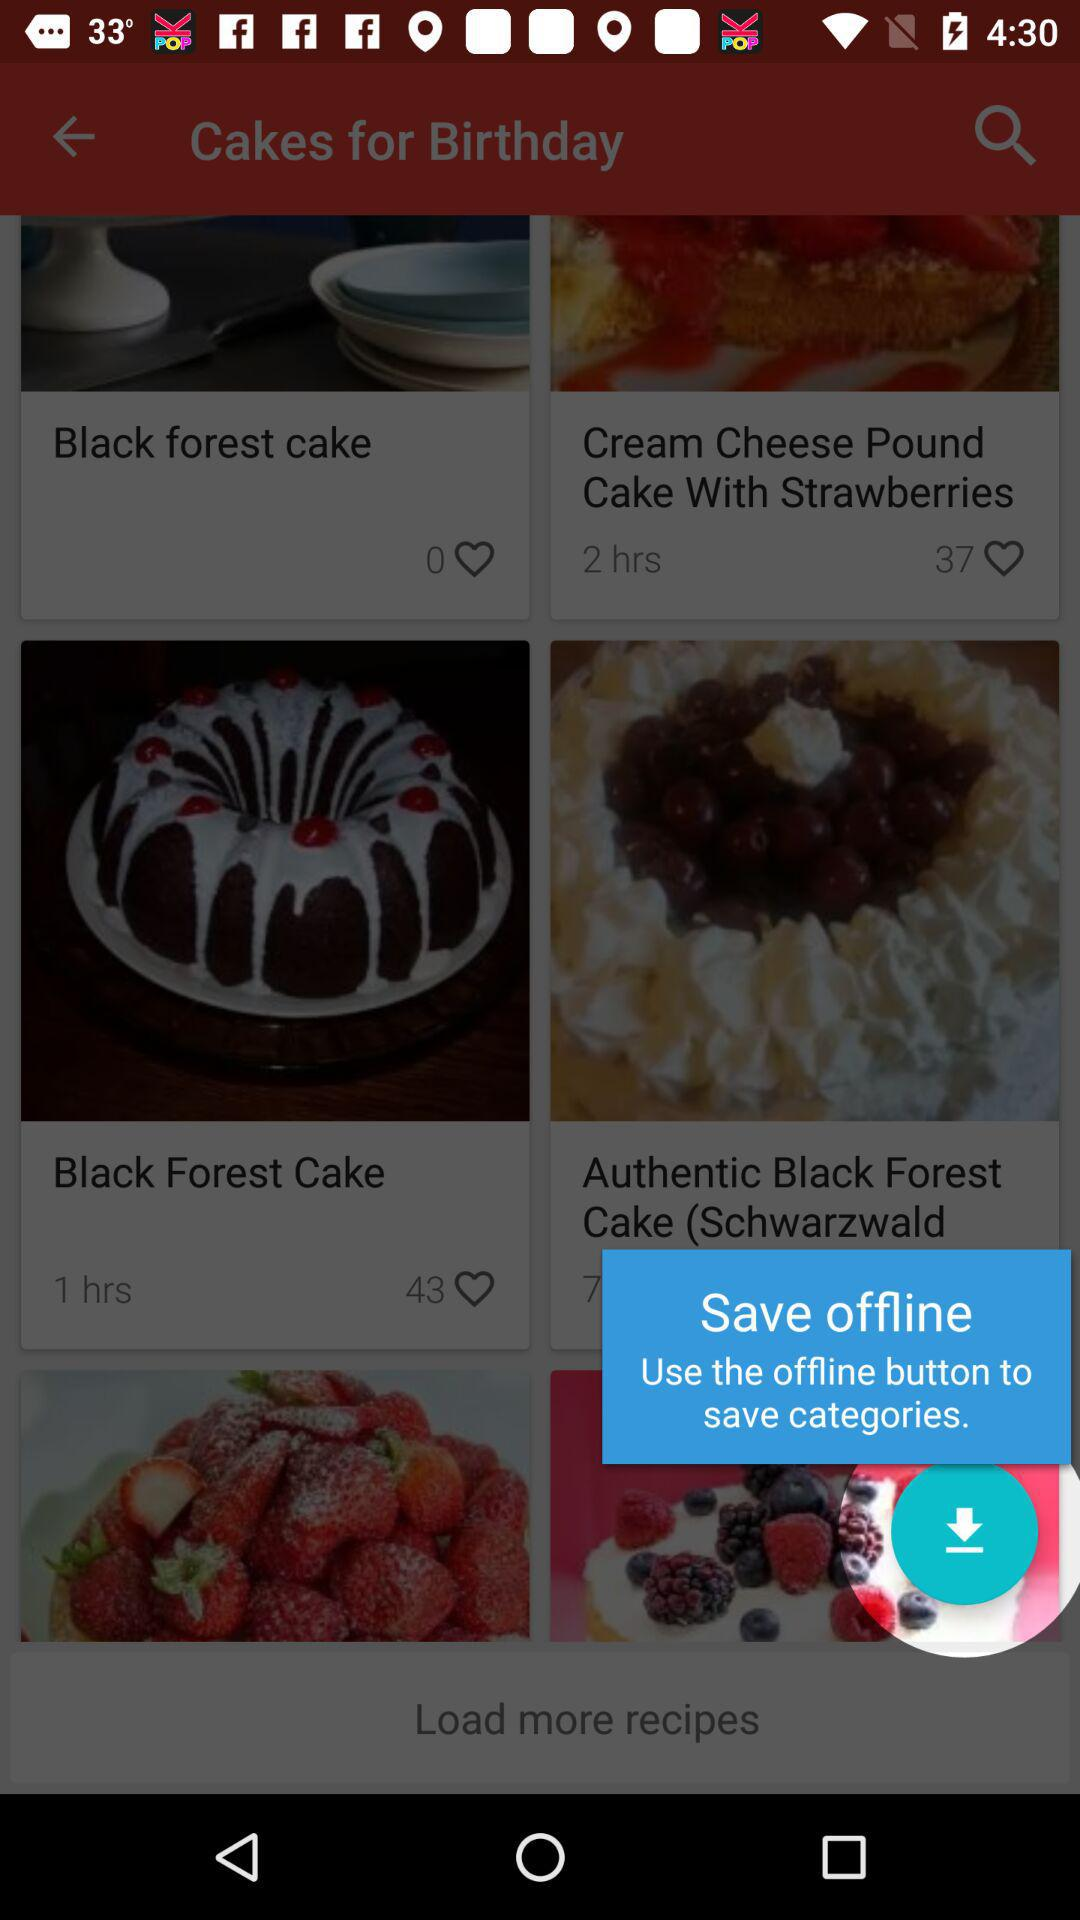What is the preparation time for "Black Forest Cake"? The preparation time for "Black Forest Cake" is 1 hour. 